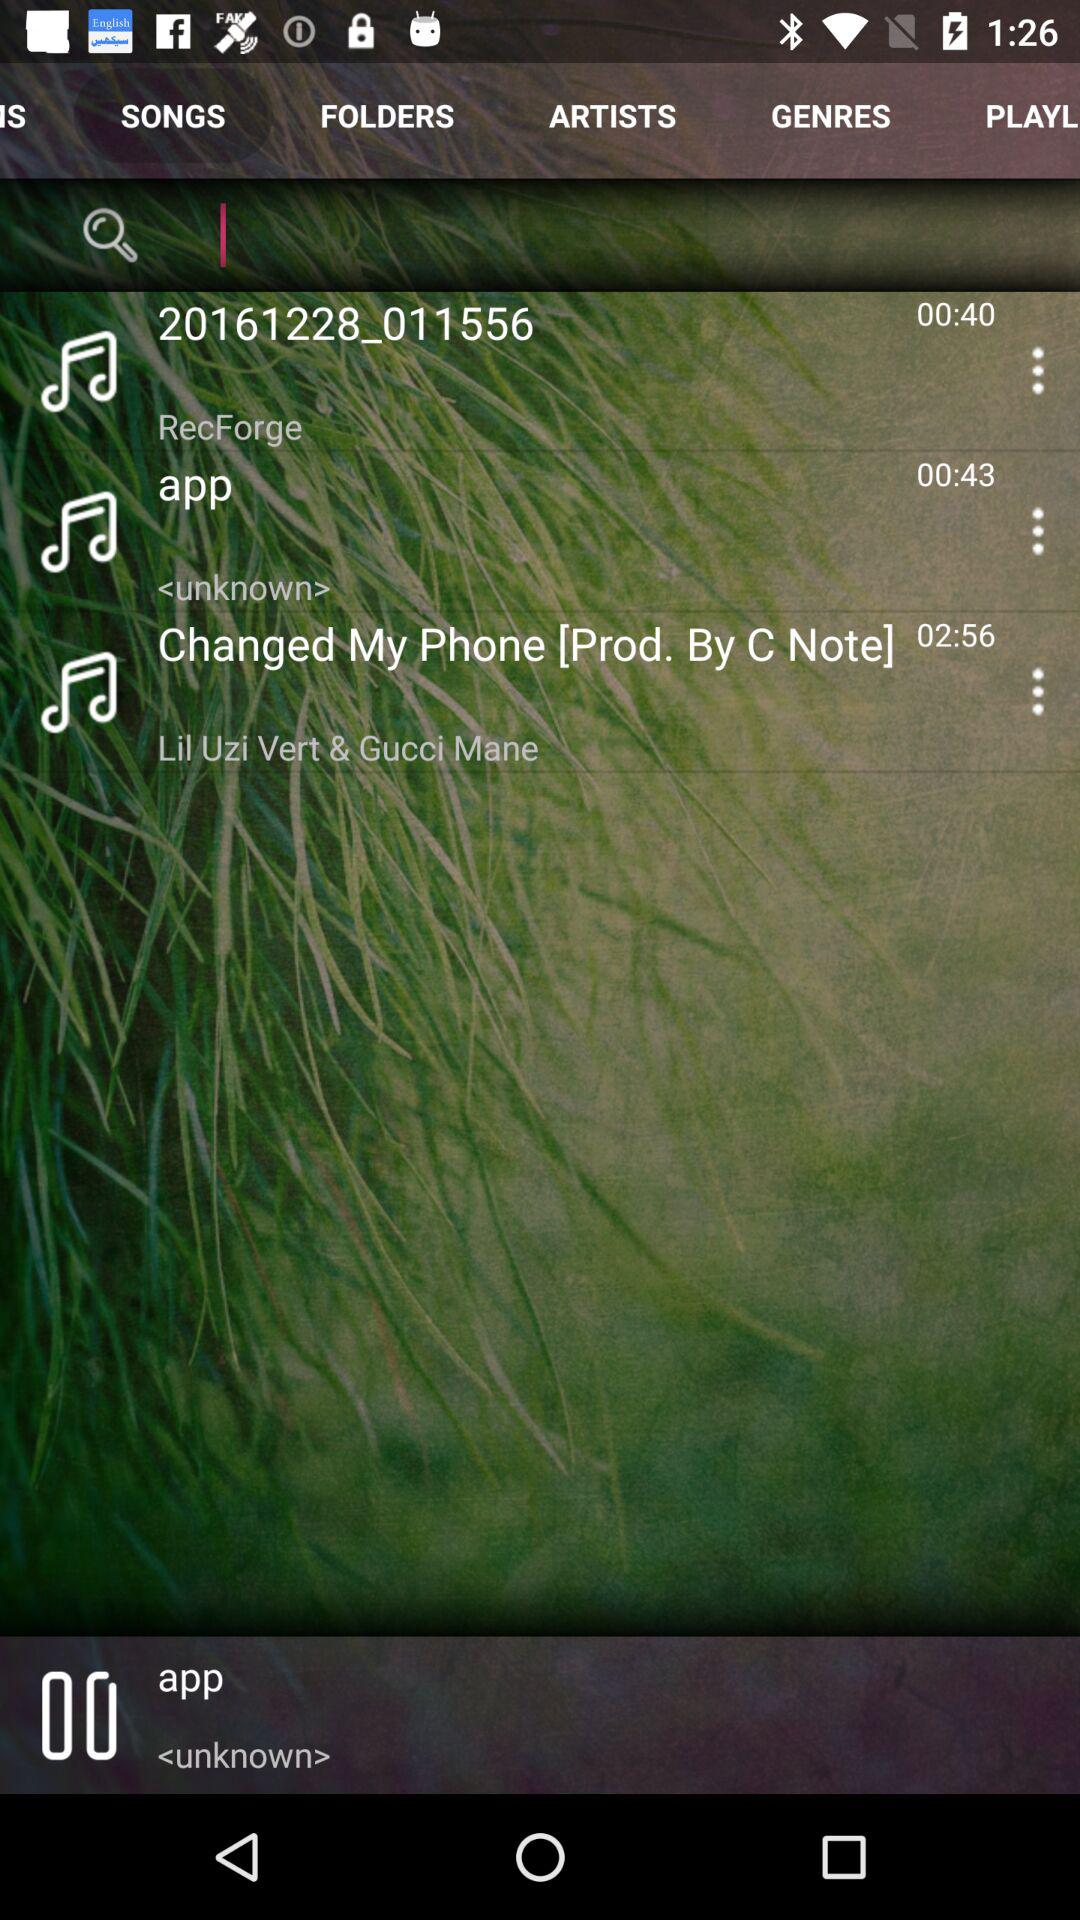What is the duration of the "Changed My Phone" song? The duration is 02:56. 